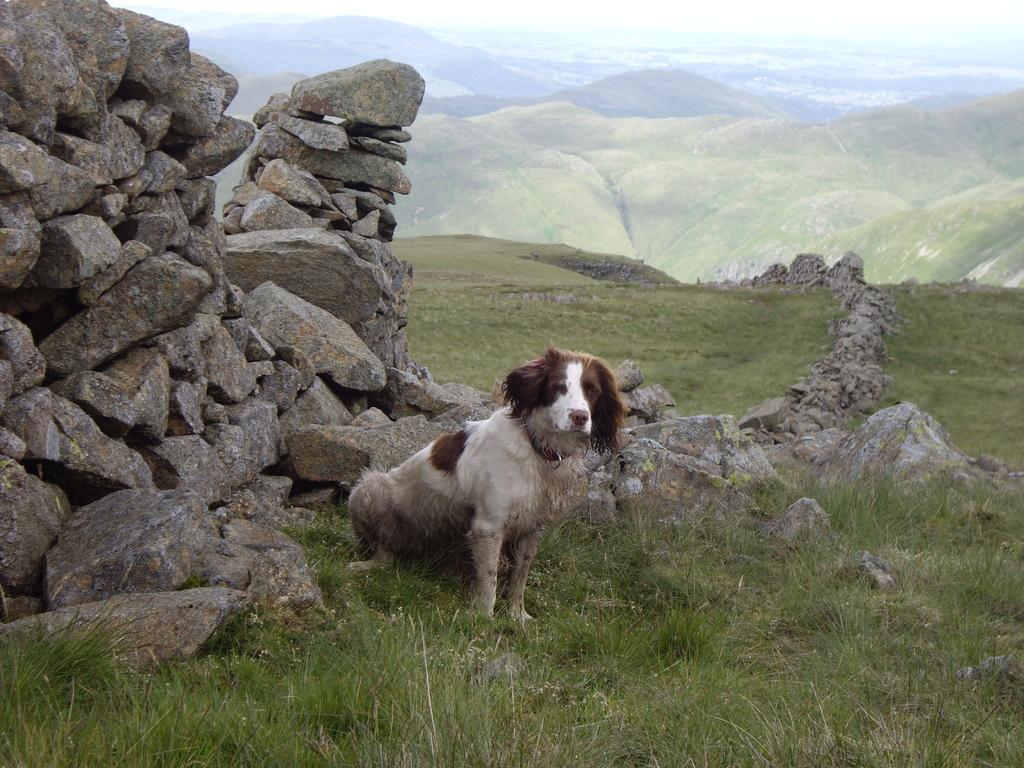Could you give a brief overview of what you see in this image? In this image I can see the dog which is in brown and white color. I can see many rocks. In the background I can see the mountains and the sky. 